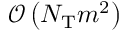Convert formula to latex. <formula><loc_0><loc_0><loc_500><loc_500>\mathcal { O } \left ( N _ { T } m ^ { 2 } \right )</formula> 